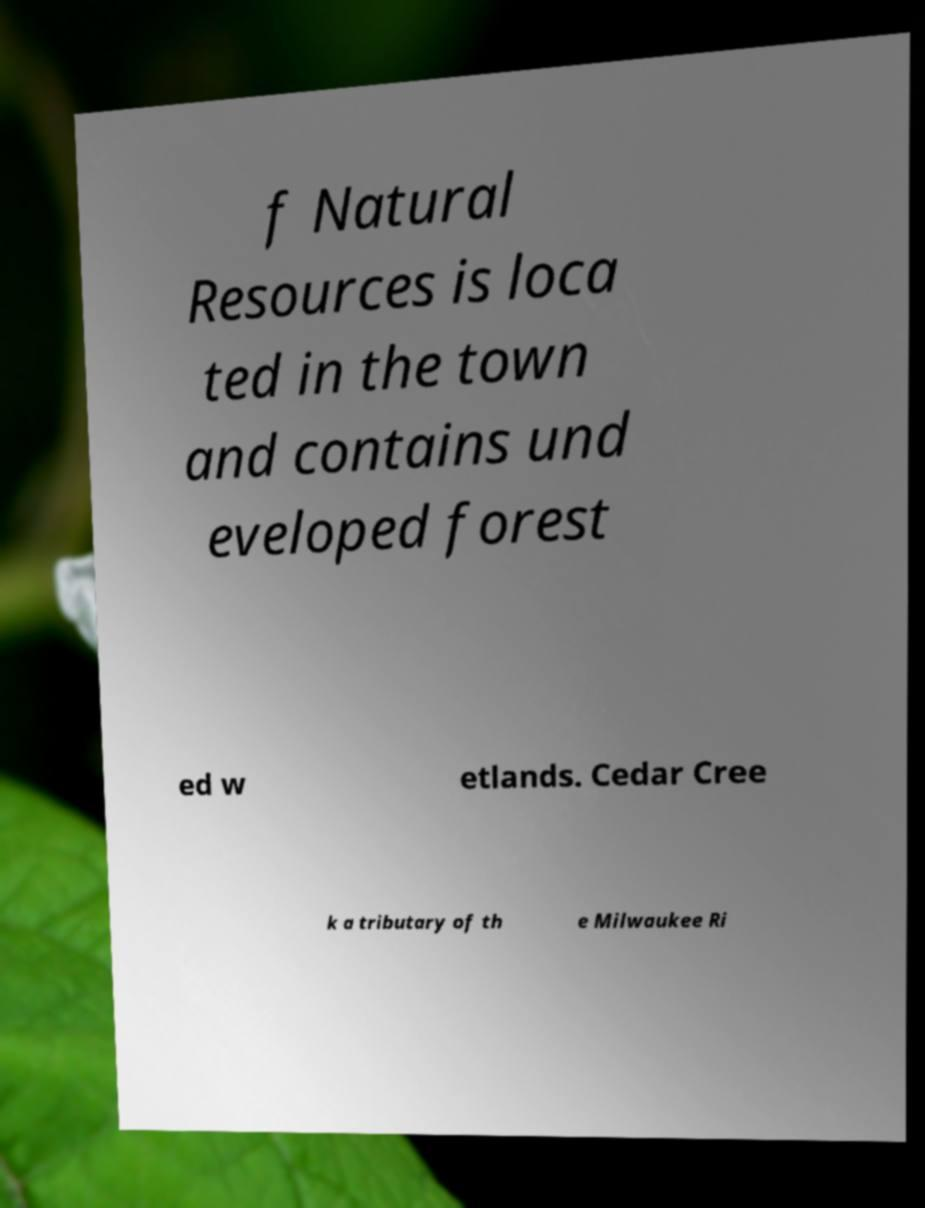What messages or text are displayed in this image? I need them in a readable, typed format. f Natural Resources is loca ted in the town and contains und eveloped forest ed w etlands. Cedar Cree k a tributary of th e Milwaukee Ri 